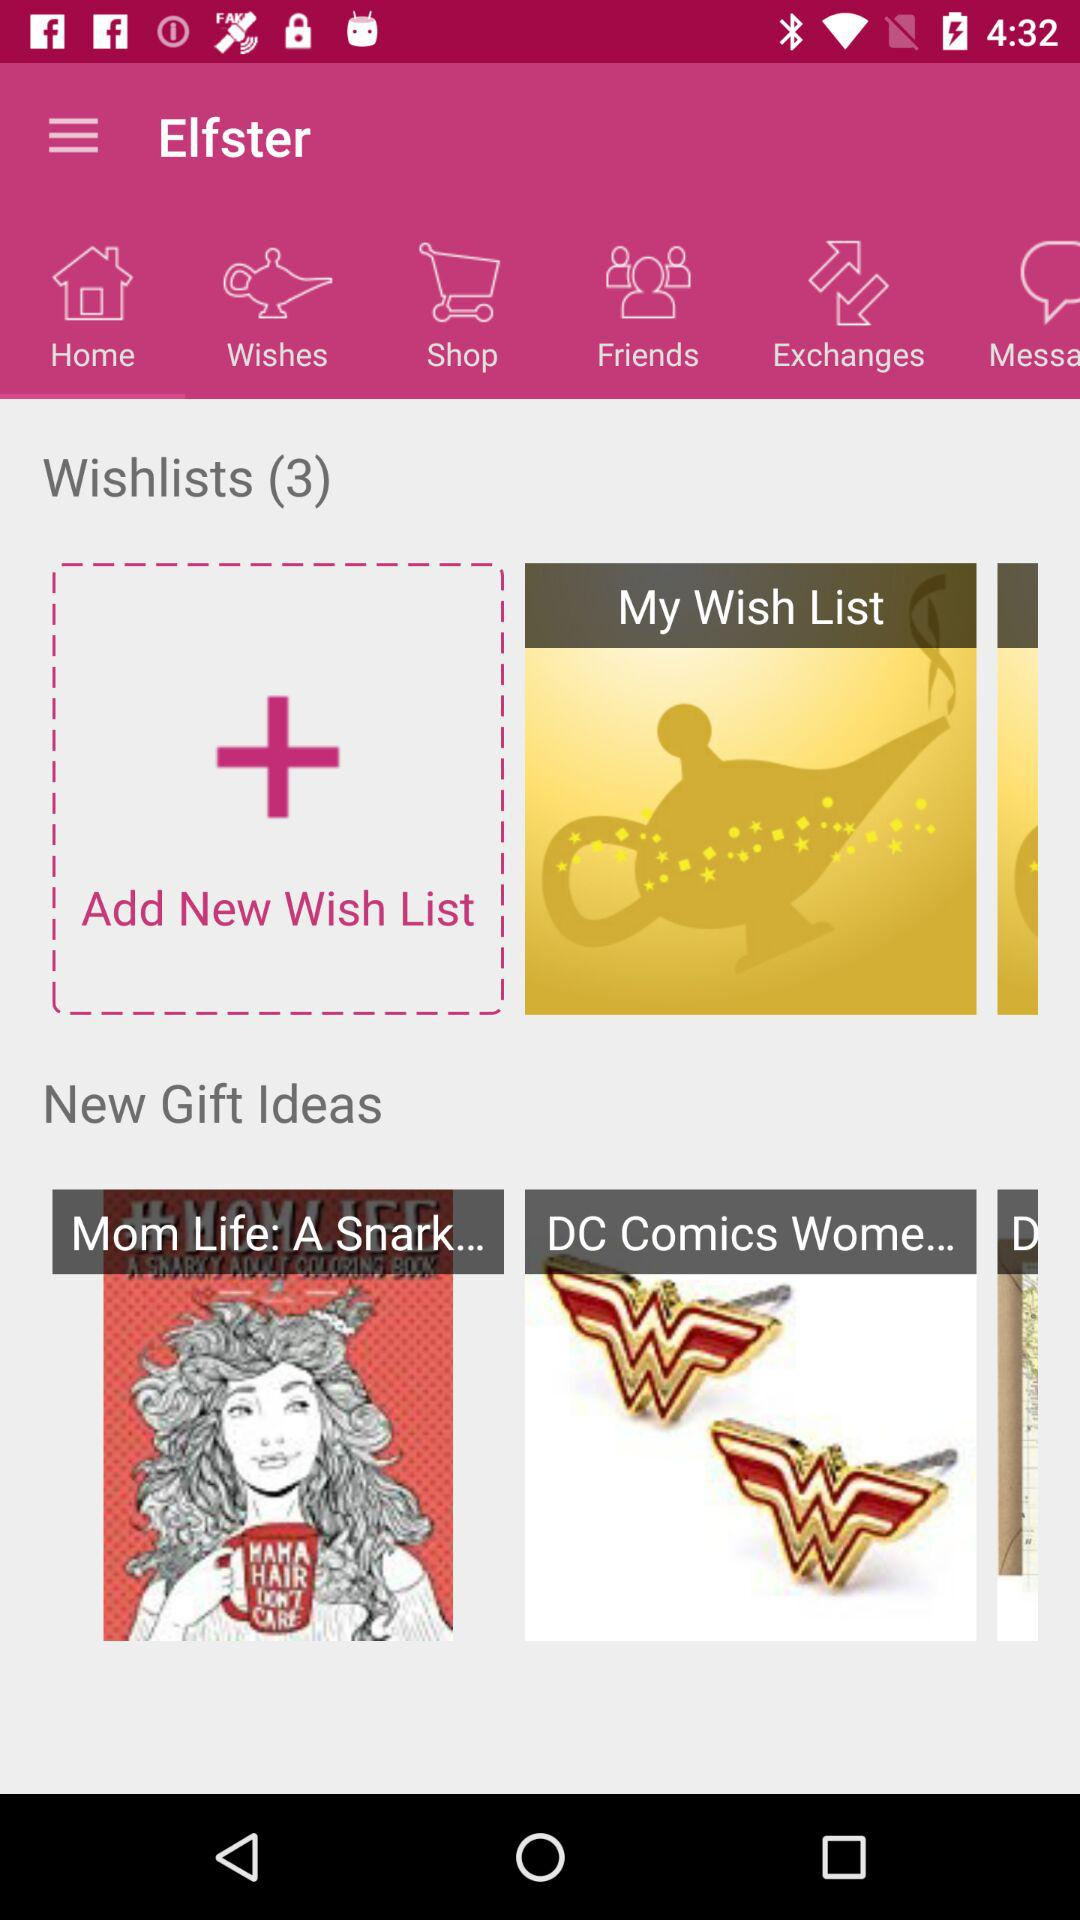How many ideas are added to the wishlists? There are 3 ideas added to the wishlists. 